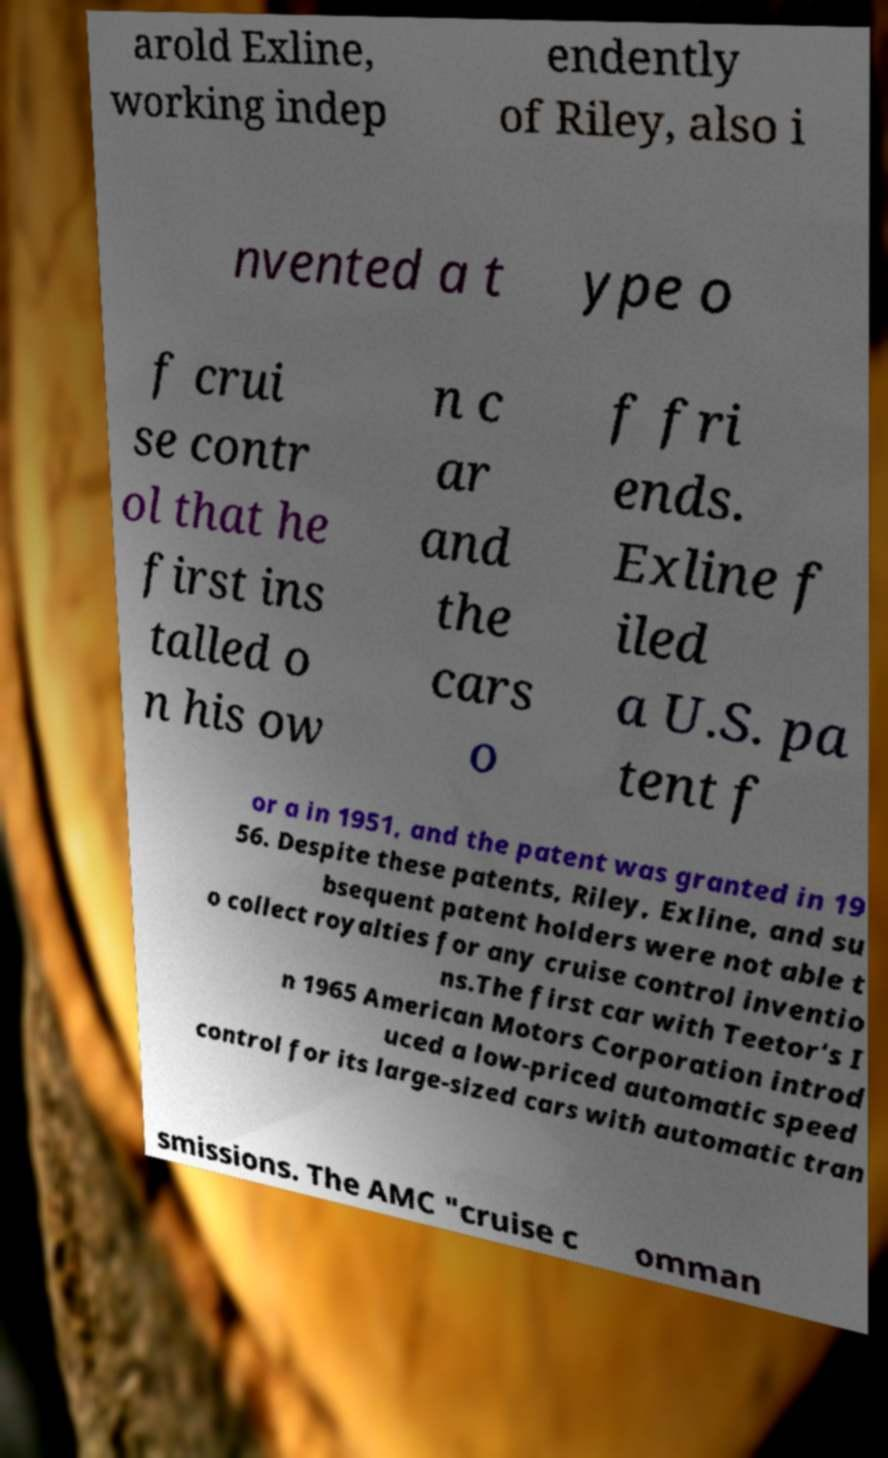Could you extract and type out the text from this image? arold Exline, working indep endently of Riley, also i nvented a t ype o f crui se contr ol that he first ins talled o n his ow n c ar and the cars o f fri ends. Exline f iled a U.S. pa tent f or a in 1951, and the patent was granted in 19 56. Despite these patents, Riley, Exline, and su bsequent patent holders were not able t o collect royalties for any cruise control inventio ns.The first car with Teetor's I n 1965 American Motors Corporation introd uced a low-priced automatic speed control for its large-sized cars with automatic tran smissions. The AMC "cruise c omman 